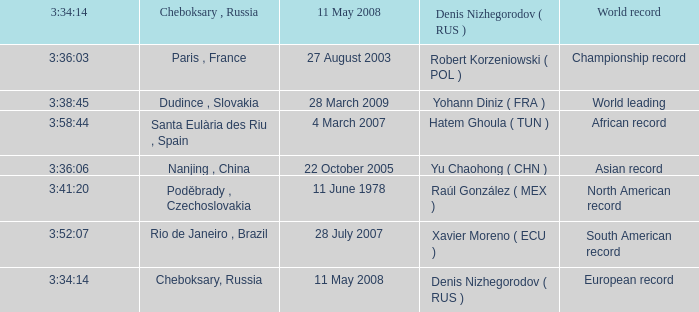When 3:38:45 is  3:34:14 what is the date on May 11th, 2008? 28 March 2009. 